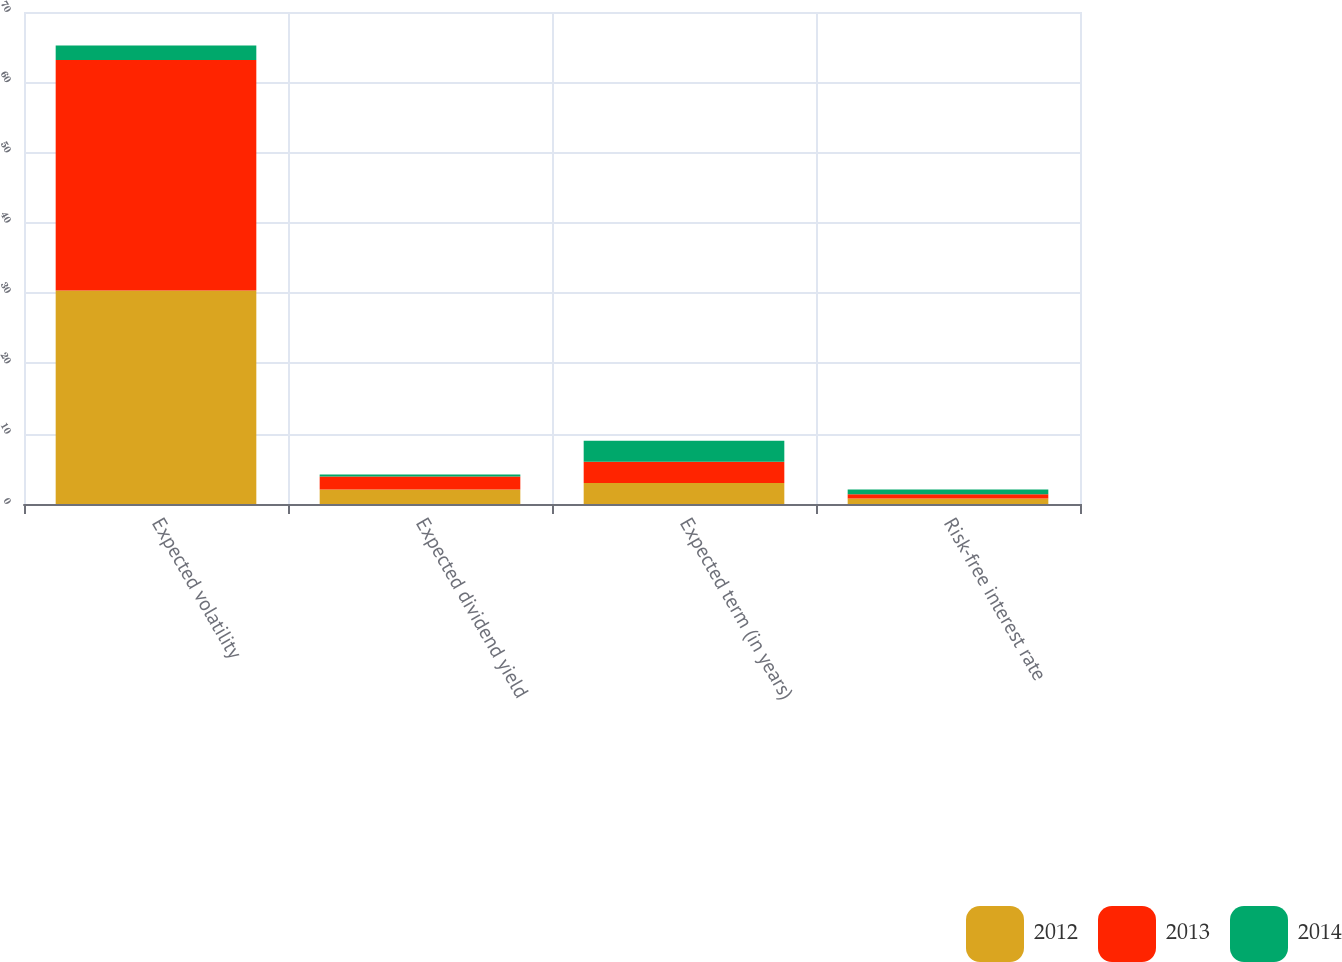Convert chart. <chart><loc_0><loc_0><loc_500><loc_500><stacked_bar_chart><ecel><fcel>Expected volatility<fcel>Expected dividend yield<fcel>Expected term (in years)<fcel>Risk-free interest rate<nl><fcel>2012<fcel>30.39<fcel>2.08<fcel>3<fcel>0.77<nl><fcel>2013<fcel>32.78<fcel>1.85<fcel>3<fcel>0.61<nl><fcel>2014<fcel>2.08<fcel>0.28<fcel>3<fcel>0.69<nl></chart> 